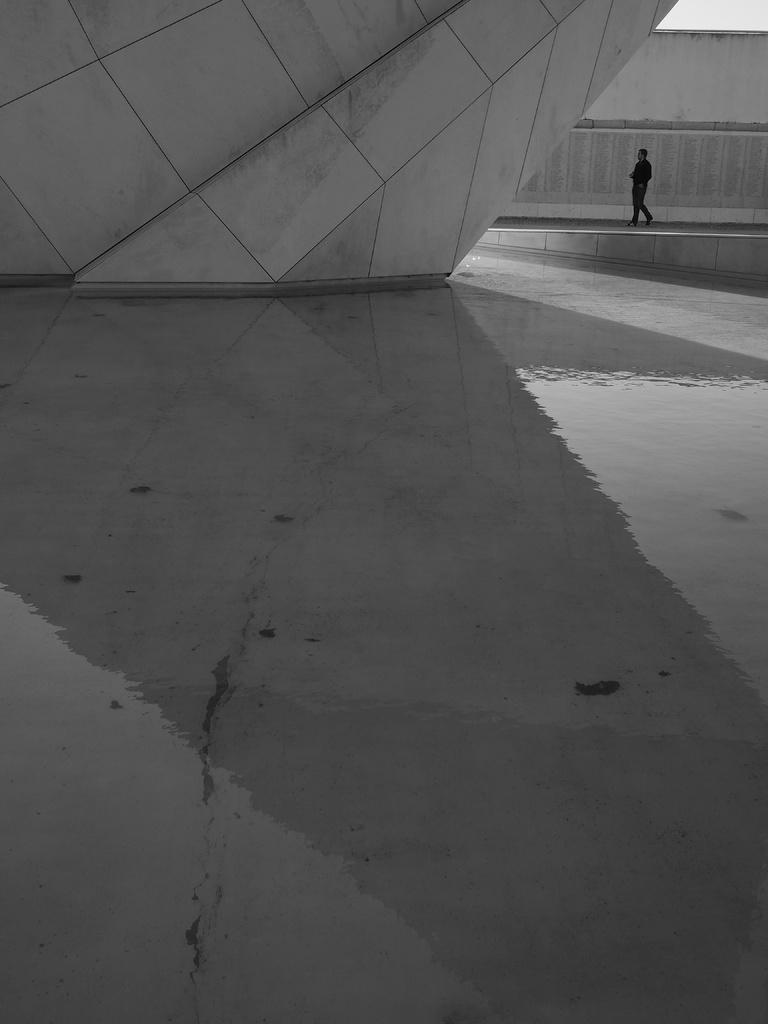What is the main action being performed by the person in the image? The person is walking in the image. On what surface is the person walking? The person is walking on the floor. What is visible behind the person? There is a wall behind the person. What is present on the floor in the image? There is some water on the floor. What is visible at the top of the image? The top of the image has a wall. How many dolls are sitting on the sofa in the image? There is no sofa or dolls present in the image. What hand gesture is the person making in the image? The image does not show the person's hands or any hand gestures. 